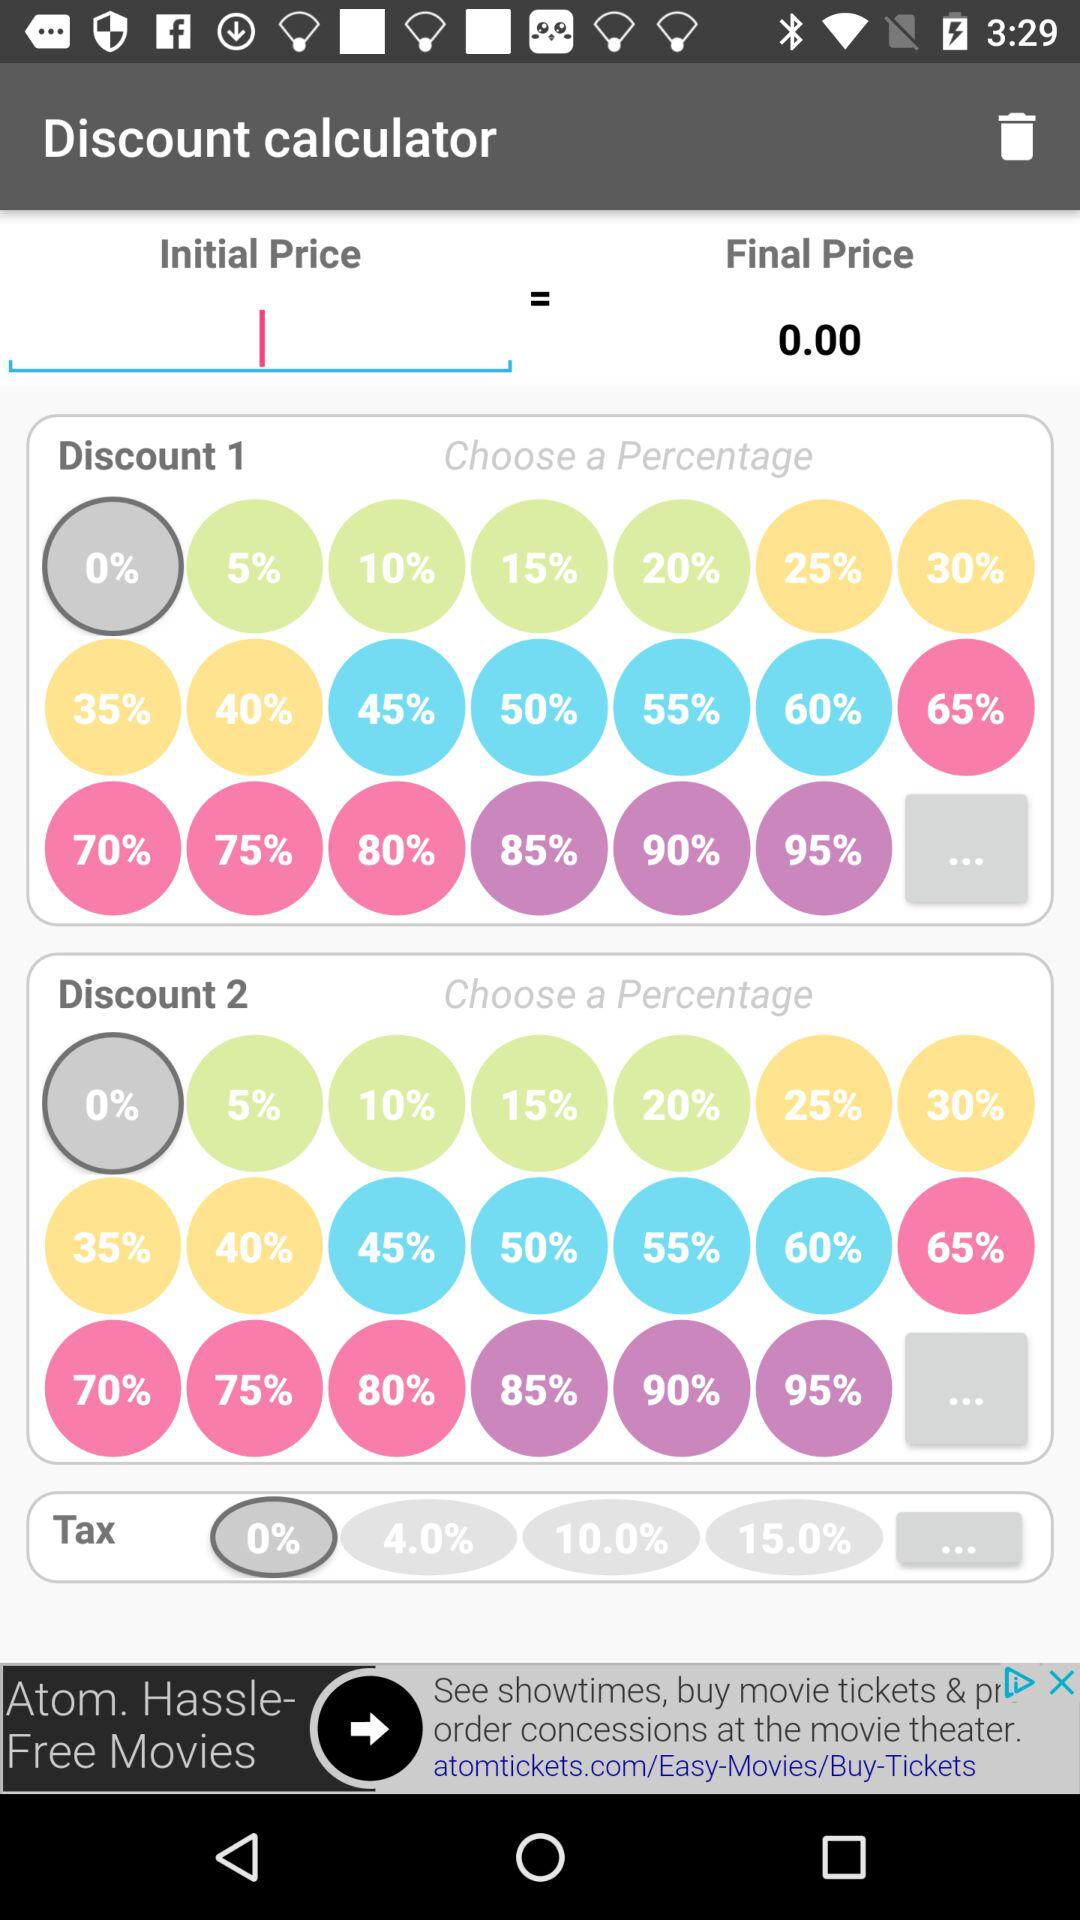What is the value of the final price? The value of the final price is 0.00. 